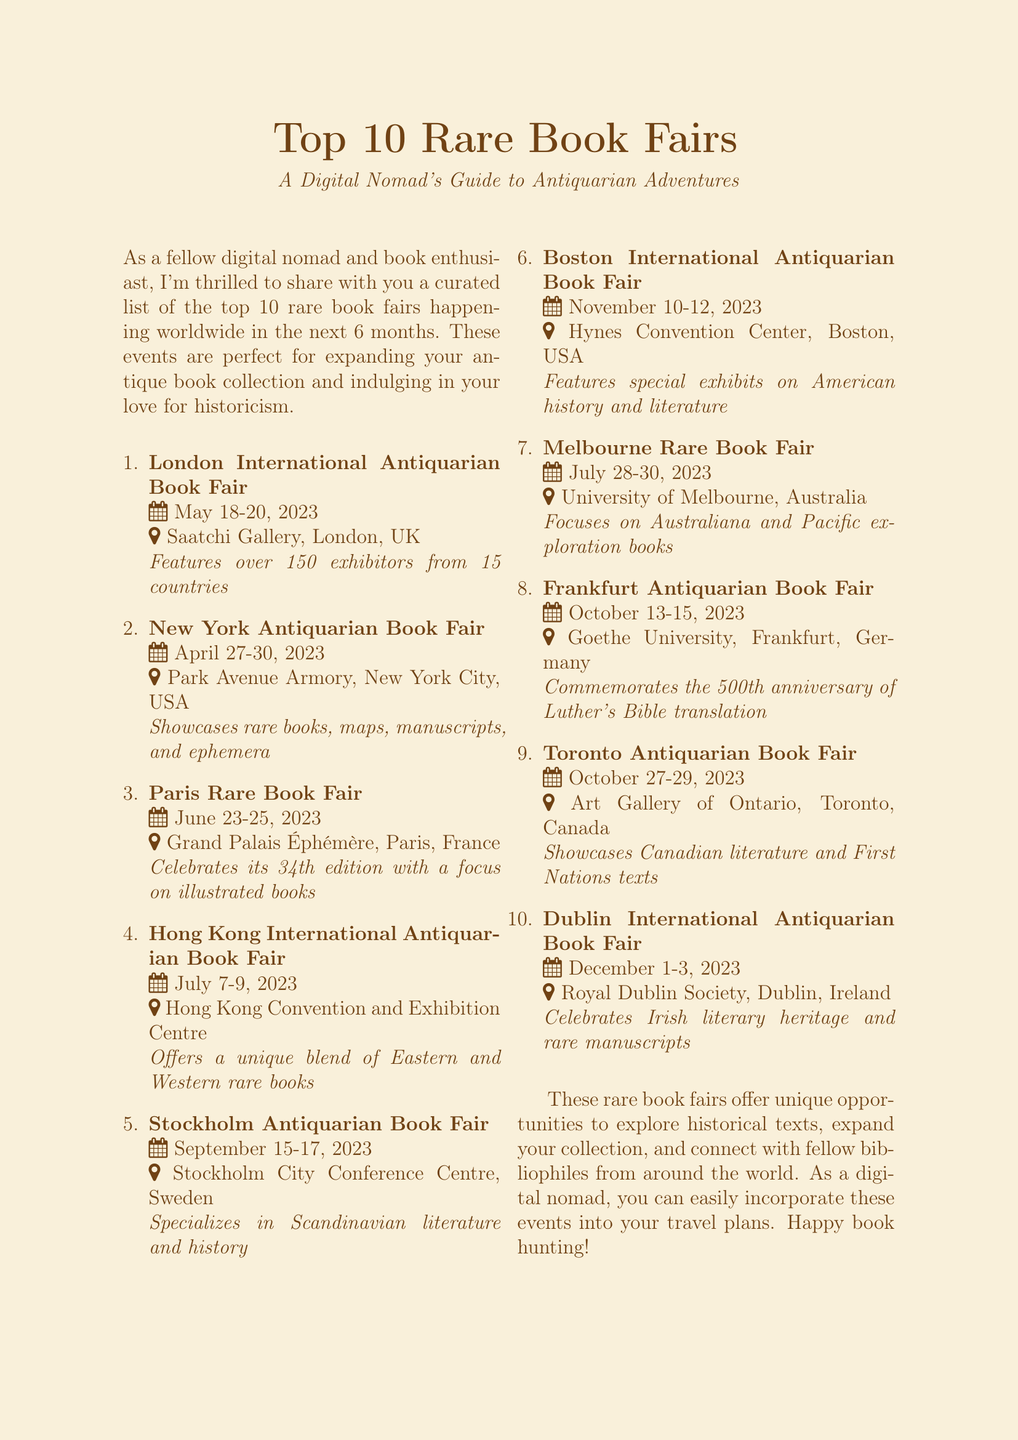What is the date of the London International Antiquarian Book Fair? The date is mentioned in the document as May 18-20, 2023.
Answer: May 18-20, 2023 Where is the New York Antiquarian Book Fair held? The location specified in the document is Park Avenue Armory, New York City, USA.
Answer: Park Avenue Armory, New York City, USA How many exhibitors are featured at the London International Antiquarian Book Fair? The document states that there are over 150 exhibitors from 15 countries.
Answer: 150 Which book fair focuses on illustrated books? The document highlights that the Paris Rare Book Fair celebrates its 34th edition with a focus on illustrated books.
Answer: Paris Rare Book Fair What is a highlight of the Boston International Antiquarian Book Fair? The document mentions that it features special exhibits on American history and literature.
Answer: Special exhibits on American history and literature Which country hosts the Frankfurt Antiquarian Book Fair? The document indicates that it takes place in Frankfurt, Germany.
Answer: Germany How many rare book fairs are mentioned in total? The total number of fairs listed in the document is ten.
Answer: Ten When is the Dublin International Antiquarian Book Fair scheduled? According to the document, the fair is scheduled for December 1-3, 2023.
Answer: December 1-3, 2023 